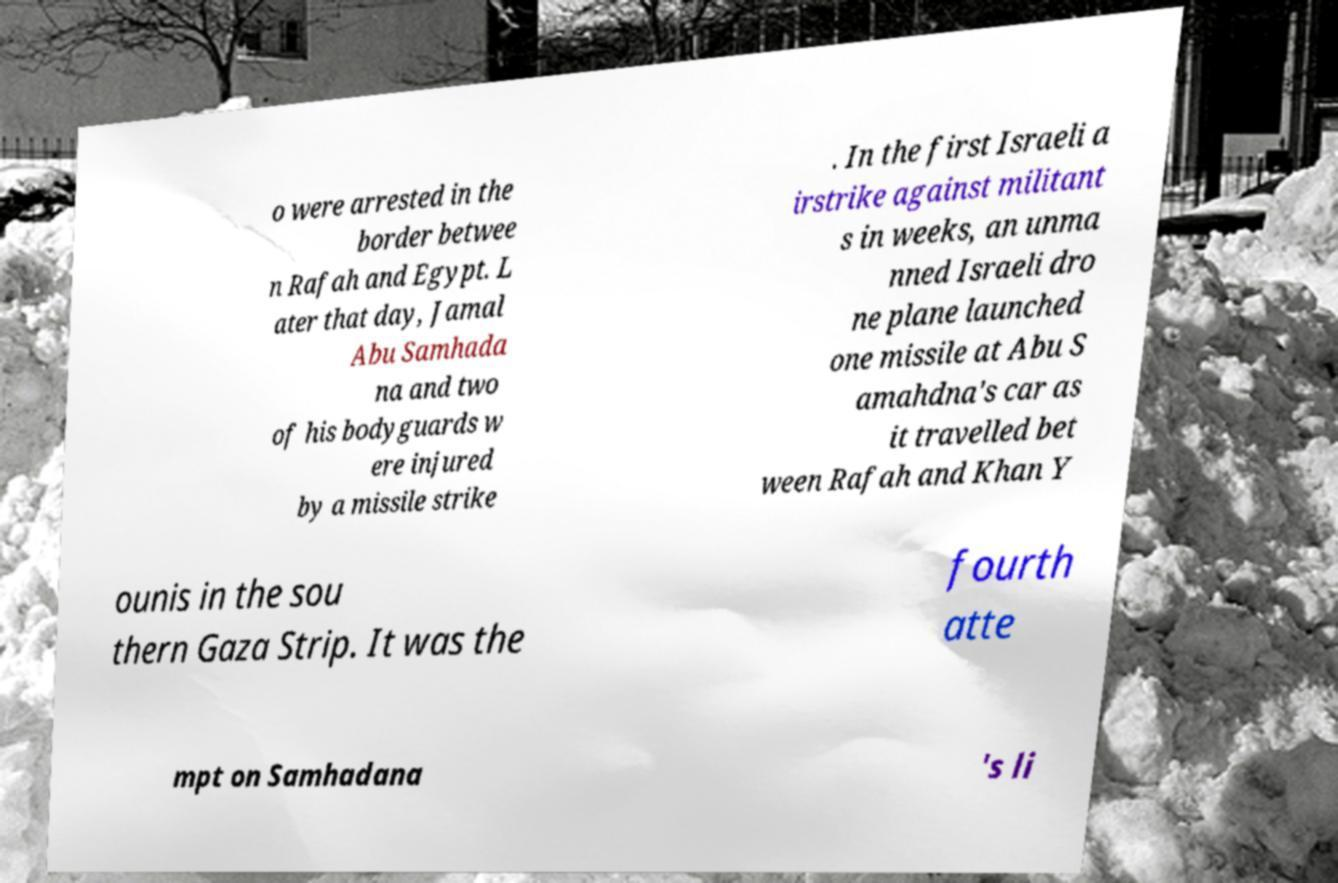I need the written content from this picture converted into text. Can you do that? o were arrested in the border betwee n Rafah and Egypt. L ater that day, Jamal Abu Samhada na and two of his bodyguards w ere injured by a missile strike . In the first Israeli a irstrike against militant s in weeks, an unma nned Israeli dro ne plane launched one missile at Abu S amahdna's car as it travelled bet ween Rafah and Khan Y ounis in the sou thern Gaza Strip. It was the fourth atte mpt on Samhadana 's li 